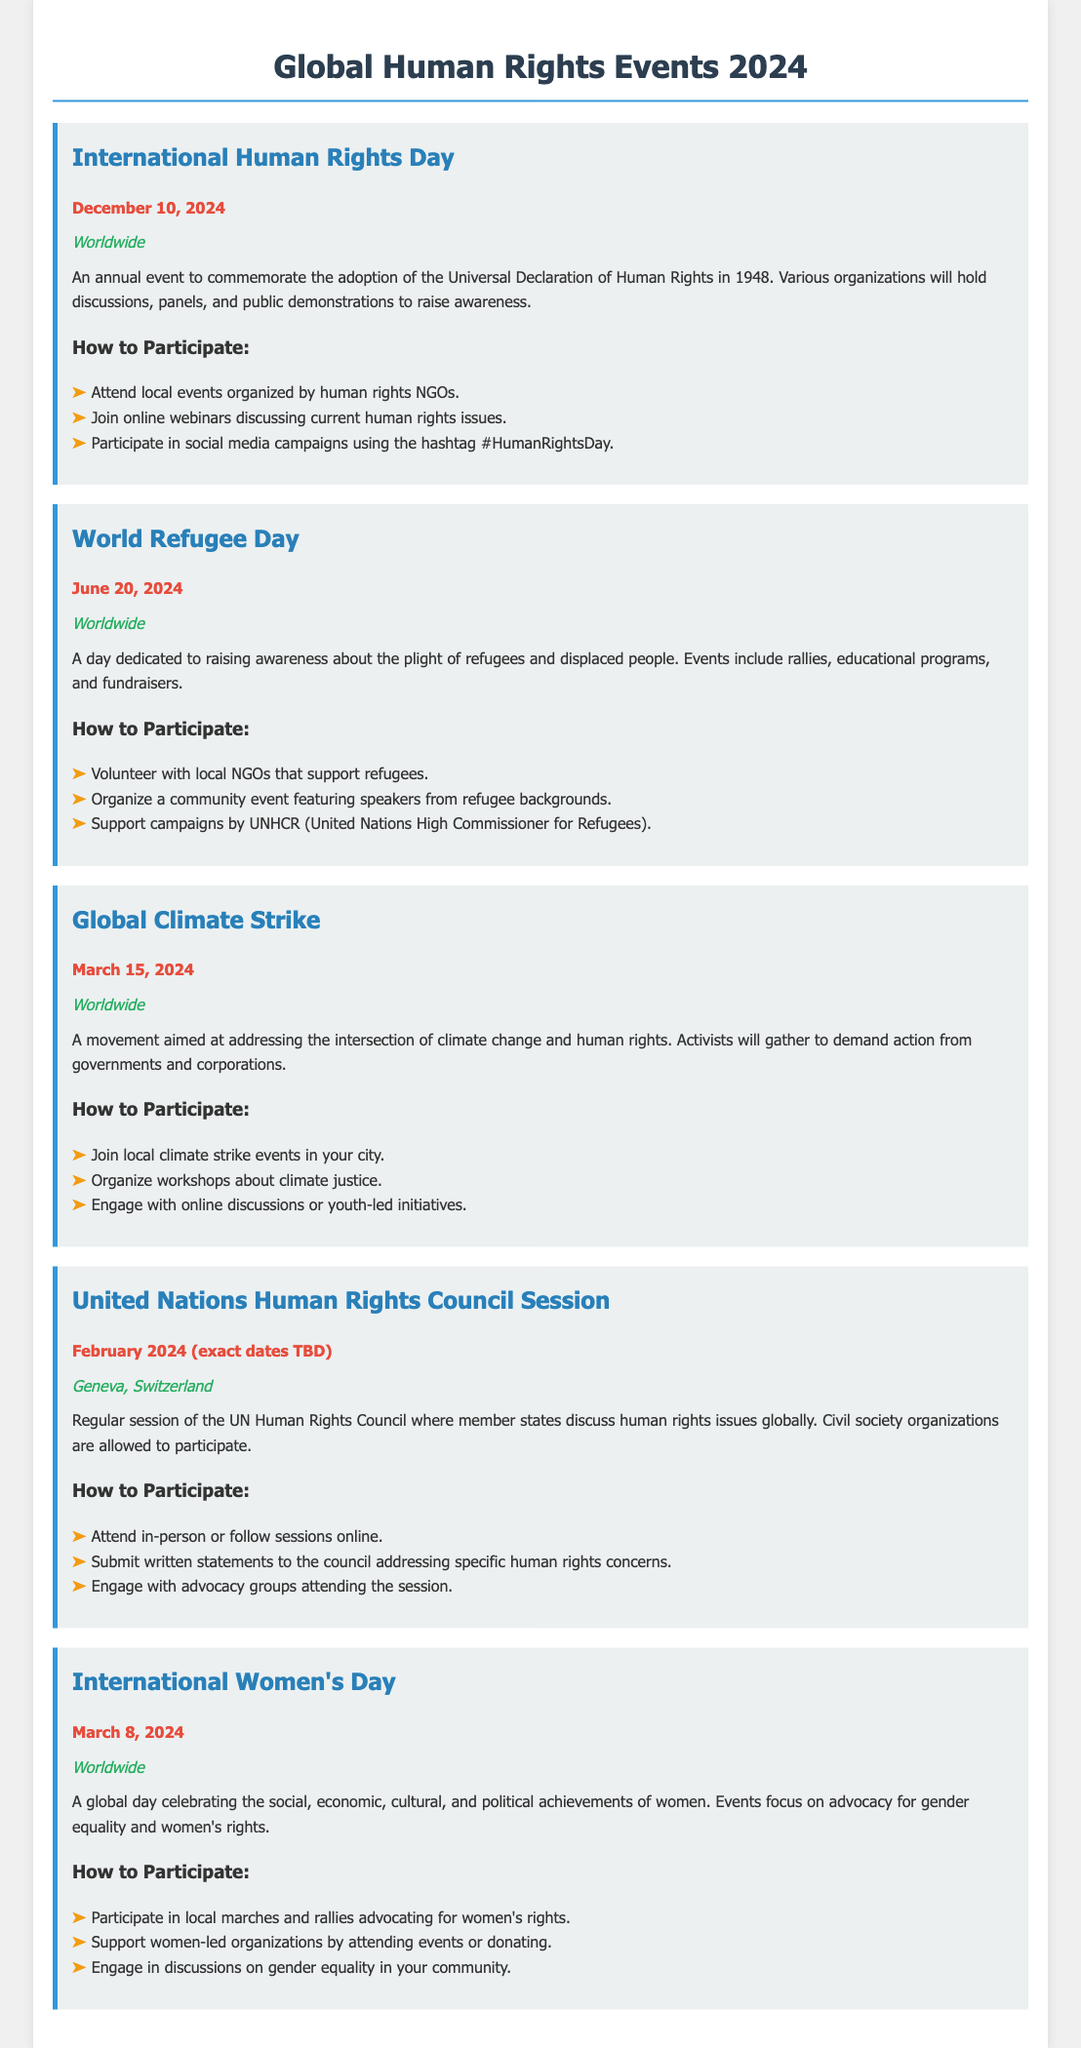What is the date of International Human Rights Day? The document states that International Human Rights Day is on December 10, 2024.
Answer: December 10, 2024 Where will the United Nations Human Rights Council Session take place? According to the document, the United Nations Human Rights Council Session will be held in Geneva, Switzerland.
Answer: Geneva, Switzerland What campaign is scheduled for June 20, 2024? The document lists World Refugee Day as an event on June 20, 2024.
Answer: World Refugee Day What are participants encouraged to do for the Global Climate Strike? The document suggests that participants join local climate strike events in their city.
Answer: Join local climate strike events Which event focuses on gender equality? The document specifies that International Women's Day focuses on advocacy for gender equality.
Answer: International Women's Day How can individuals participate in International Women's Day? The document outlines that individuals can participate in local marches and rallies advocating for women's rights.
Answer: Local marches and rallies What type of activities are planned for World Refugee Day? The document describes activities such as rallies, educational programs, and fundraisers for World Refugee Day.
Answer: Rallies, educational programs, and fundraisers What is the main focus of International Human Rights Day? The document highlights that the main focus is to commemorate the adoption of the Universal Declaration of Human Rights.
Answer: Commemorate the adoption of the Universal Declaration of Human Rights What is a way to engage with the United Nations Human Rights Council Session? The document mentions that individuals can submit written statements to the council addressing specific human rights concerns.
Answer: Submit written statements 